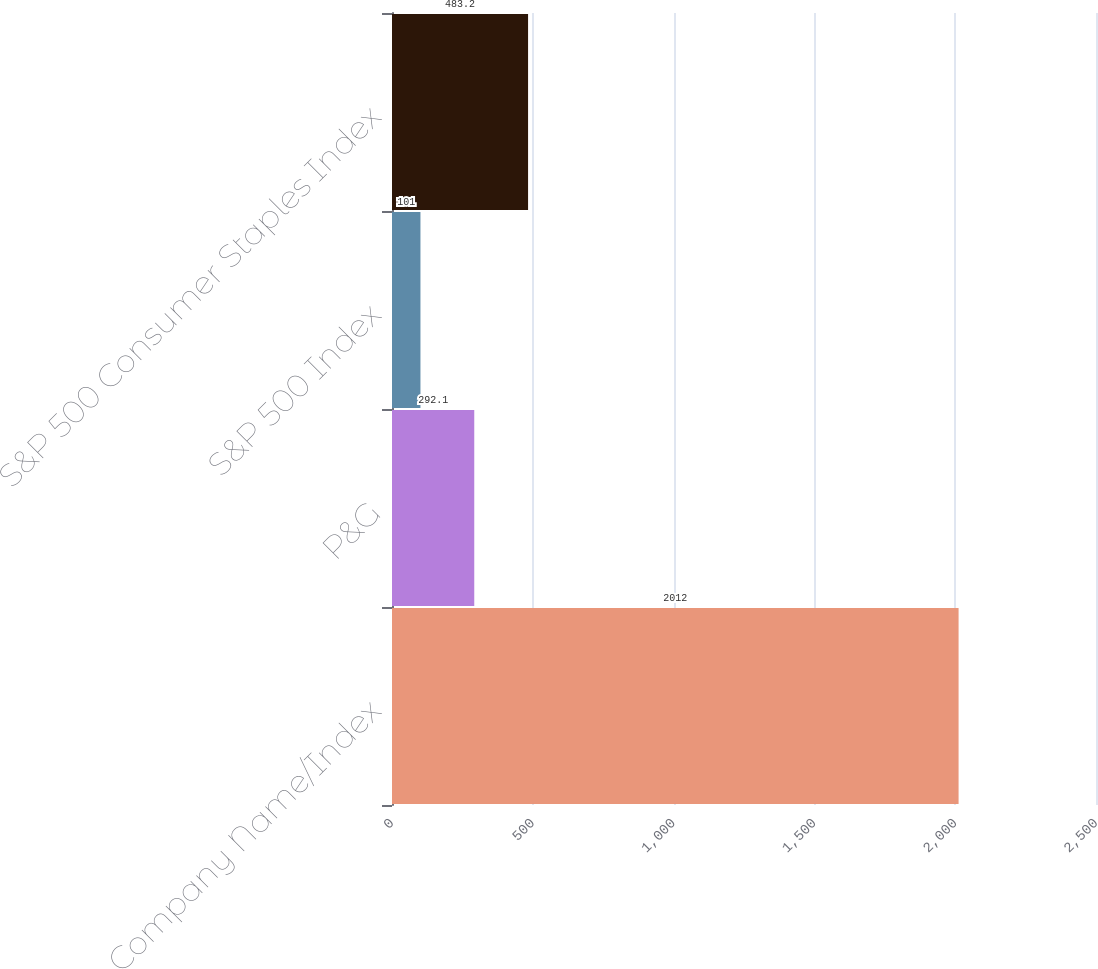<chart> <loc_0><loc_0><loc_500><loc_500><bar_chart><fcel>Company Name/Index<fcel>P&G<fcel>S&P 500 Index<fcel>S&P 500 Consumer Staples Index<nl><fcel>2012<fcel>292.1<fcel>101<fcel>483.2<nl></chart> 